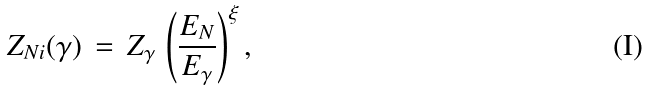<formula> <loc_0><loc_0><loc_500><loc_500>Z _ { N i } ( \gamma ) \, = \, Z _ { \gamma } \, \left ( \frac { E _ { N } } { E _ { \gamma } } \right ) ^ { \xi } ,</formula> 